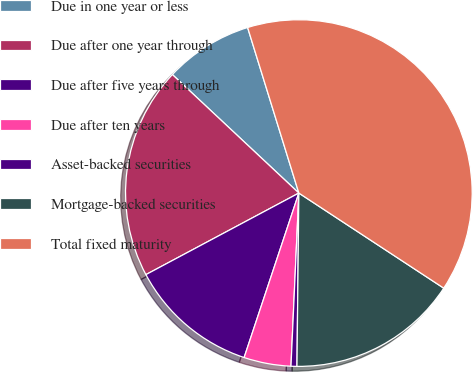Convert chart. <chart><loc_0><loc_0><loc_500><loc_500><pie_chart><fcel>Due in one year or less<fcel>Due after one year through<fcel>Due after five years through<fcel>Due after ten years<fcel>Asset-backed securities<fcel>Mortgage-backed securities<fcel>Total fixed maturity<nl><fcel>8.24%<fcel>19.78%<fcel>12.09%<fcel>4.39%<fcel>0.55%<fcel>15.93%<fcel>39.02%<nl></chart> 